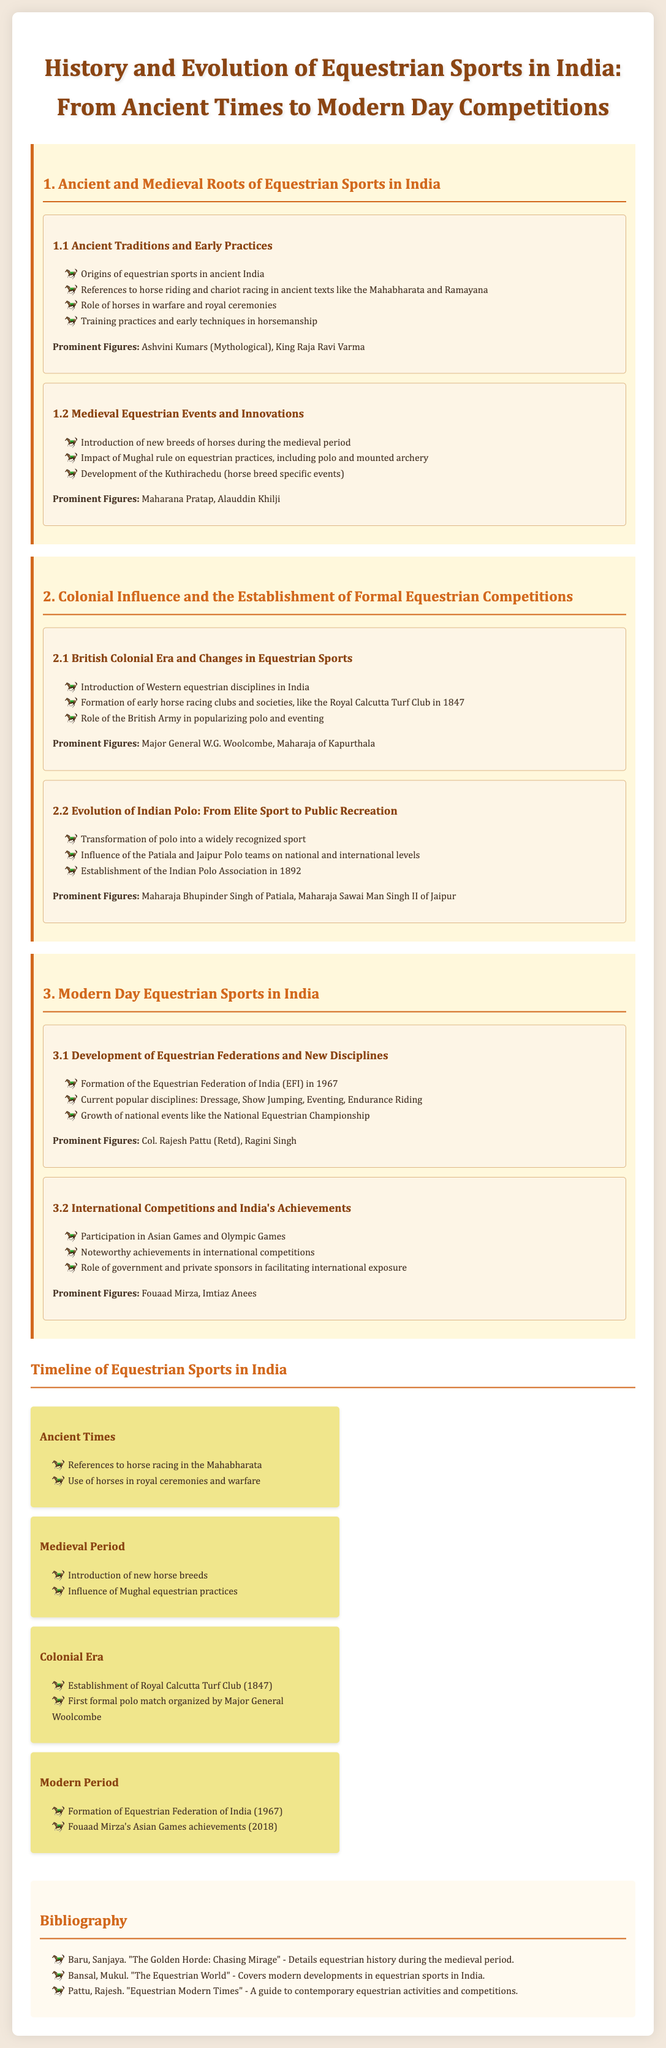What are the prominent figures mentioned in ancient equestrian sports? The prominent figures listed include Ashvini Kumars (Mythological) and King Raja Ravi Varma.
Answer: Ashvini Kumars, King Raja Ravi Varma What year was the Equestrian Federation of India formed? The document states that the Equestrian Federation of India was formed in 1967.
Answer: 1967 Which event did Major General W.G. Woolcombe organize? The document specifies that Major General W.G. Woolcombe organized the first formal polo match.
Answer: First formal polo match What were some popular equestrian disciplines noted in modern-day sports? The document highlights Dressage, Show Jumping, Eventing, and Endurance Riding as popular disciplines.
Answer: Dressage, Show Jumping, Eventing, Endurance Riding What historical period introduced new breeds of horses? The document indicates that the Medieval Period introduced new breeds of horses.
Answer: Medieval Period Which major national event is mentioned in the modern segment? The document mentions the National Equestrian Championship as a major national event.
Answer: National Equestrian Championship How many prominent figures are listed in the evolution of Indian polo? The document lists two prominent figures in the evolution of Indian polo: Maharaja Bhupinder Singh of Patiala and Maharaja Sawai Man Singh II of Jaipur.
Answer: Two What is the earliest reference to horse racing in Indian texts? The document mentions references to horse racing in the Mahabharata as the earliest reference.
Answer: Mahabharata What year was the Royal Calcutta Turf Club established? The document states that the Royal Calcutta Turf Club was established in 1847.
Answer: 1847 